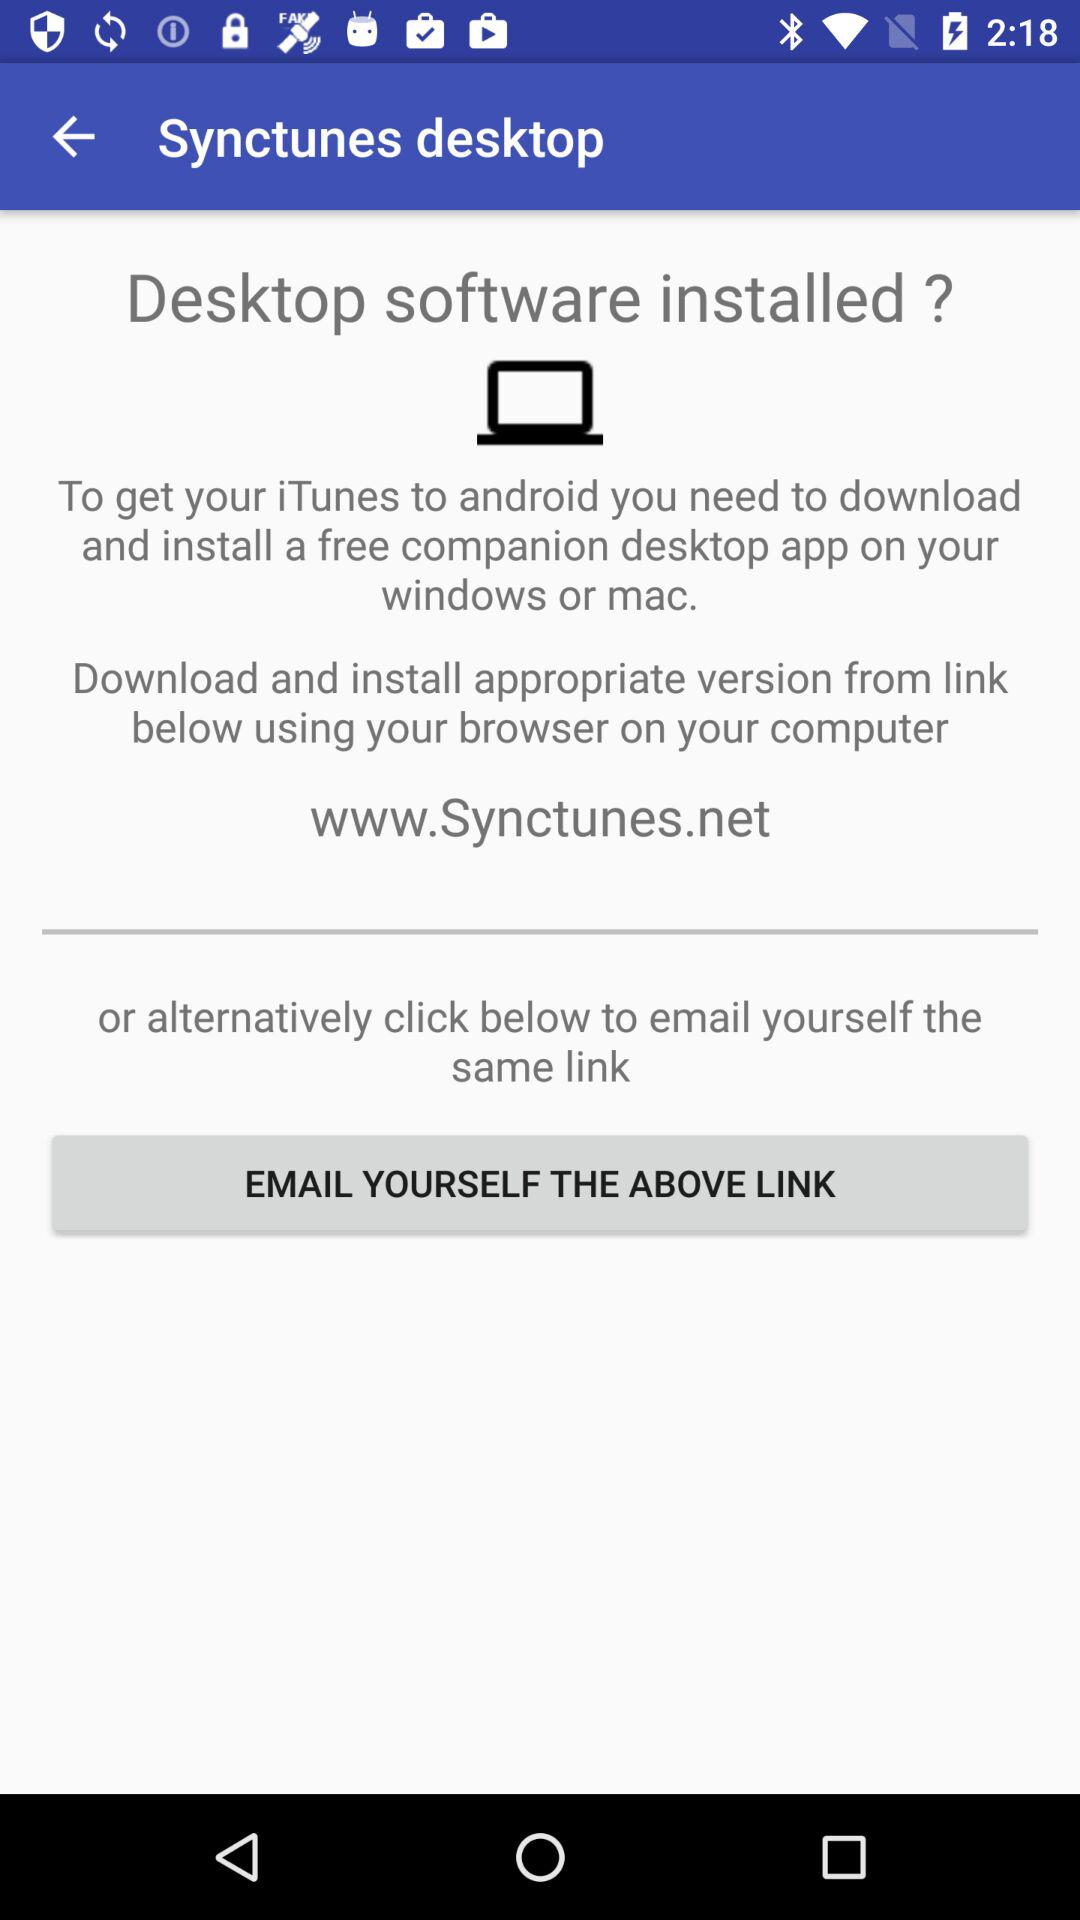What do we need to download to get iTunes to Android? You need to download a free companion desktop app on your Windows or Mac. 